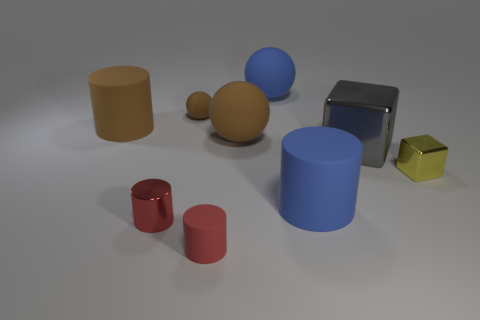There is a brown thing that is to the right of the tiny brown matte object; what number of tiny red things are on the right side of it?
Give a very brief answer. 0. The other cylinder that is the same color as the metallic cylinder is what size?
Give a very brief answer. Small. What number of objects are tiny red spheres or large matte things in front of the large gray object?
Your response must be concise. 1. Are there any large red cubes that have the same material as the big brown cylinder?
Offer a terse response. No. What number of rubber things are both to the right of the red metallic object and left of the red rubber cylinder?
Provide a short and direct response. 1. There is a big gray thing that is in front of the small matte ball; what material is it?
Your response must be concise. Metal. What is the size of the red cylinder that is the same material as the small sphere?
Offer a very short reply. Small. There is a large blue cylinder; are there any small yellow metal objects left of it?
Offer a terse response. No. The other metallic thing that is the same shape as the large gray shiny thing is what size?
Provide a short and direct response. Small. There is a small metal block; is its color the same as the big rubber cylinder that is left of the small brown rubber sphere?
Your answer should be compact. No. 